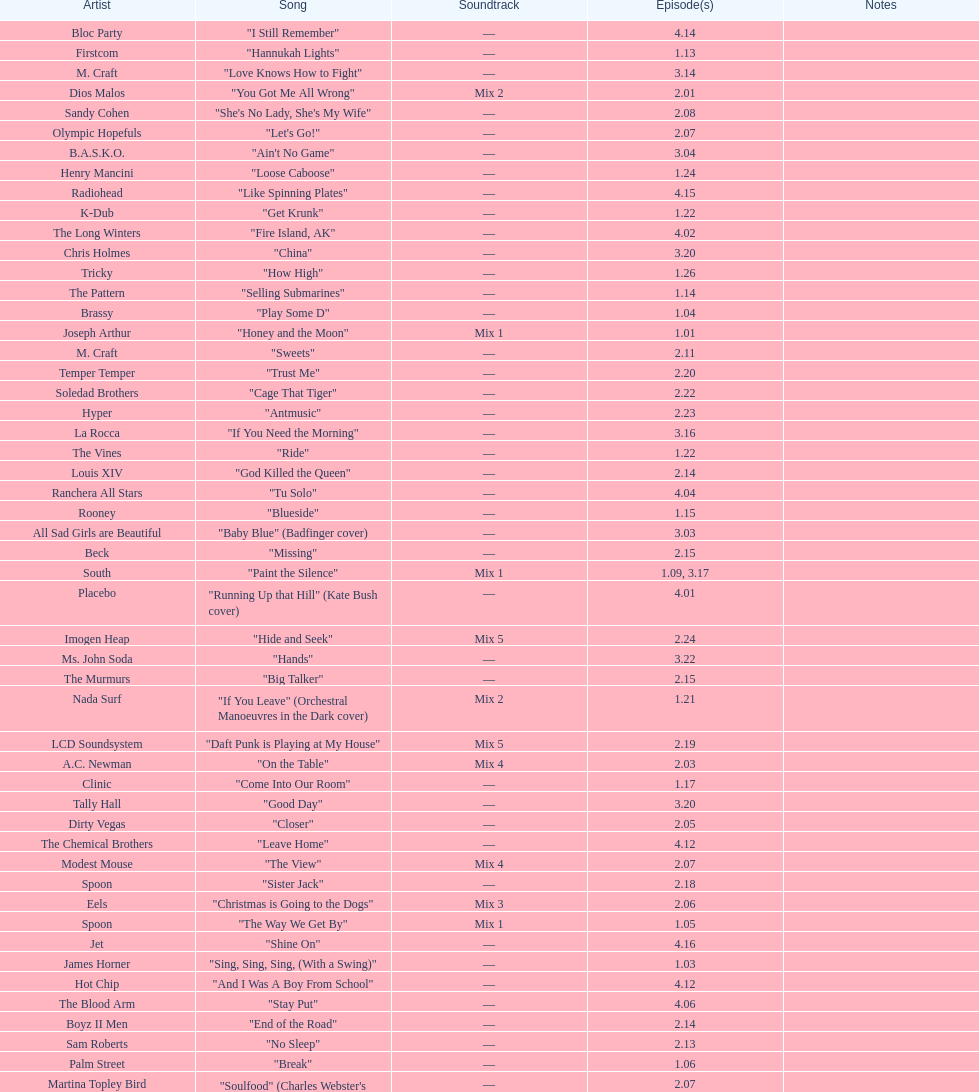"girl" and "el pro" were performed by which artist? Beck. 